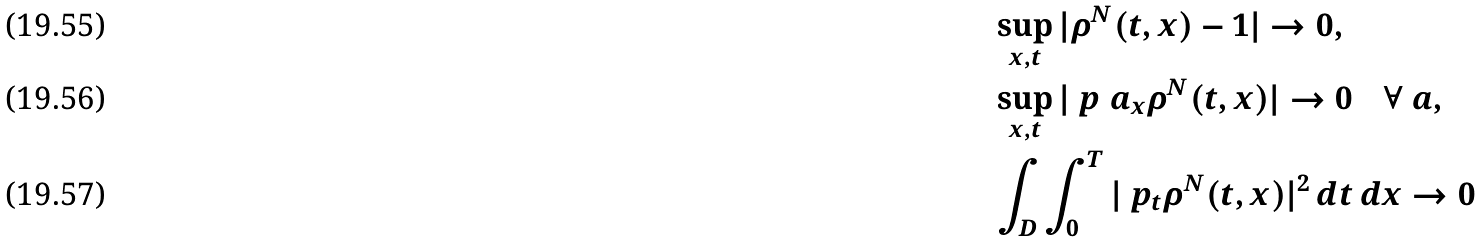<formula> <loc_0><loc_0><loc_500><loc_500>& \sup _ { x , t } | \rho ^ { N } ( t , x ) - 1 | \to 0 , \\ & \sup _ { x , t } | \ p ^ { \ } a _ { x } \rho ^ { N } ( t , x ) | \to 0 \quad \forall \ a , \\ & \int _ { D } \int _ { 0 } ^ { T } | \ p _ { t } \rho ^ { N } ( t , x ) | ^ { 2 } \, d t \, d x \to 0</formula> 